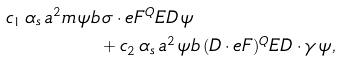Convert formula to latex. <formula><loc_0><loc_0><loc_500><loc_500>c _ { 1 } \, \alpha _ { s } \, a ^ { 2 } m \, \psi b & \, \sigma \cdot e F ^ { Q } E D \, \psi \\ & + c _ { 2 } \, \alpha _ { s } \, a ^ { 2 } \, \psi b \, ( D \cdot e F ) ^ { Q } E D \cdot \gamma \, \psi ,</formula> 